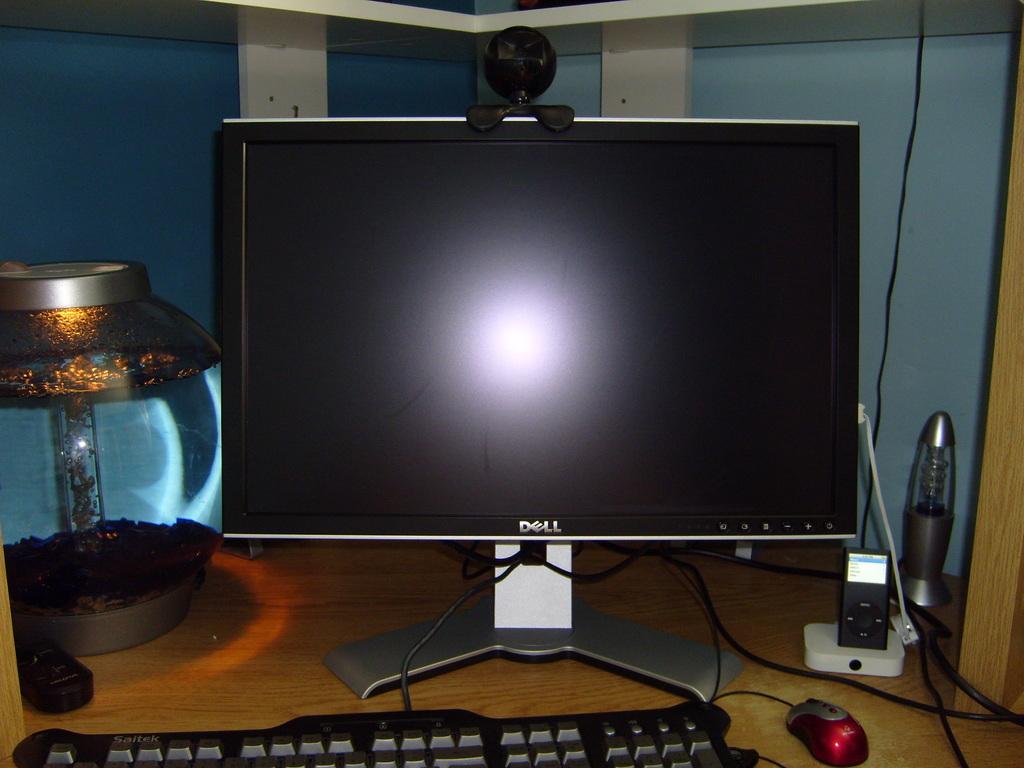Who made the computer monitor?
Offer a very short reply. Dell. What type of keyboard is that?
Offer a very short reply. Saitek. 